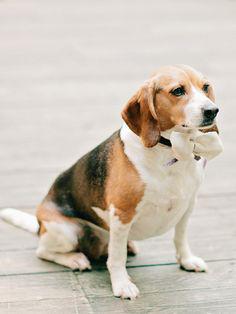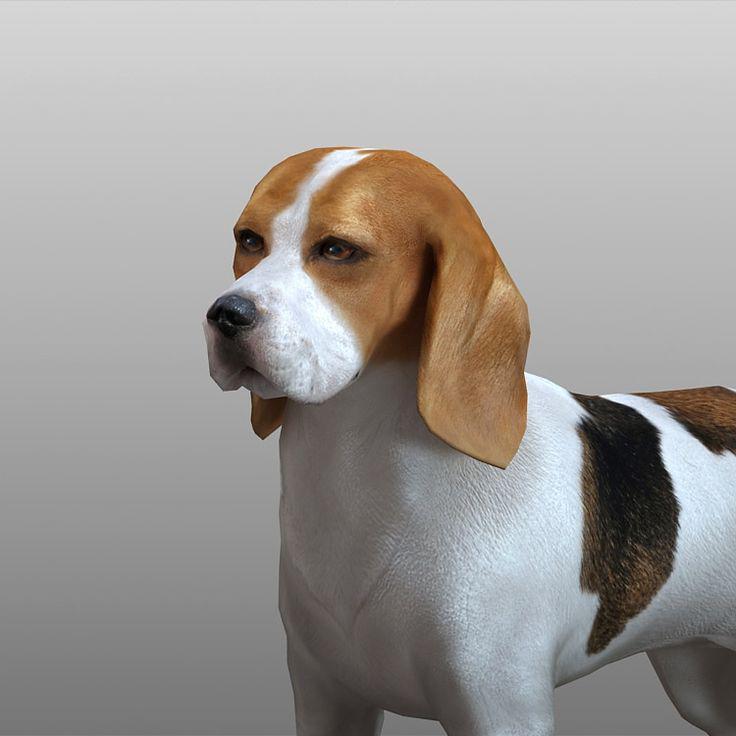The first image is the image on the left, the second image is the image on the right. Analyze the images presented: Is the assertion "In one of the images there is a real dog whose tail is standing up straight." valid? Answer yes or no. No. 